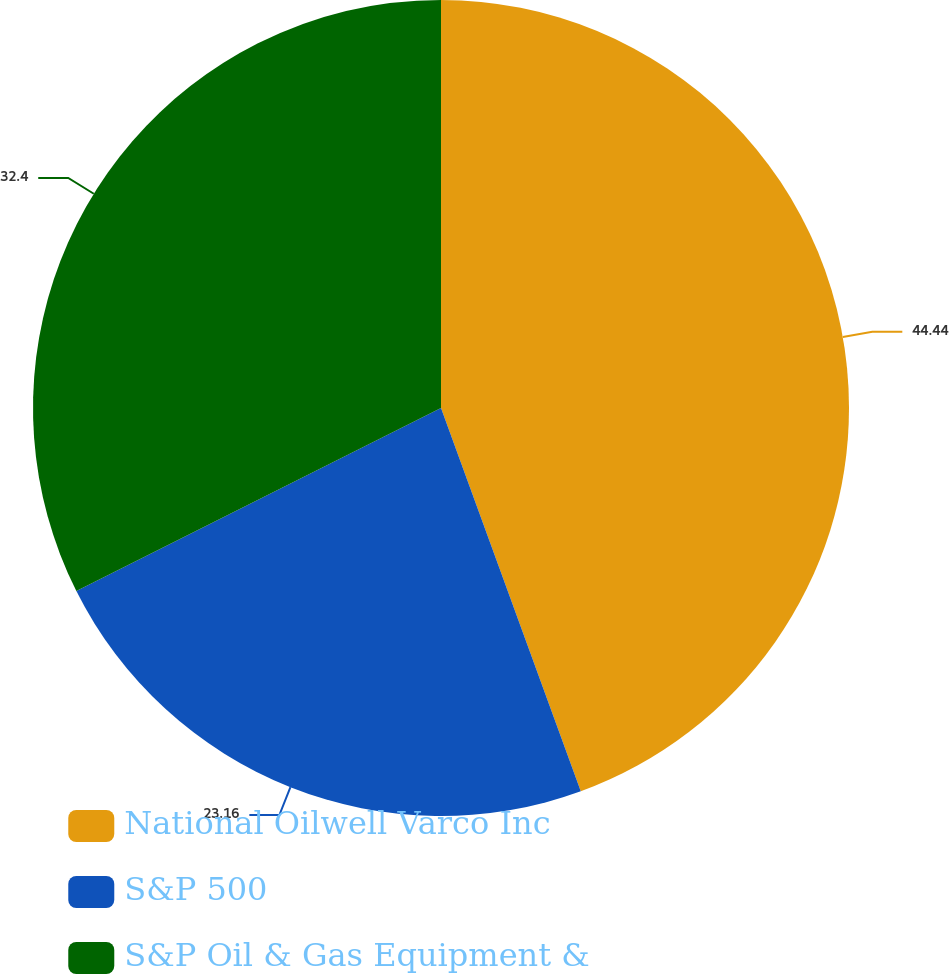Convert chart to OTSL. <chart><loc_0><loc_0><loc_500><loc_500><pie_chart><fcel>National Oilwell Varco Inc<fcel>S&P 500<fcel>S&P Oil & Gas Equipment &<nl><fcel>44.43%<fcel>23.16%<fcel>32.4%<nl></chart> 